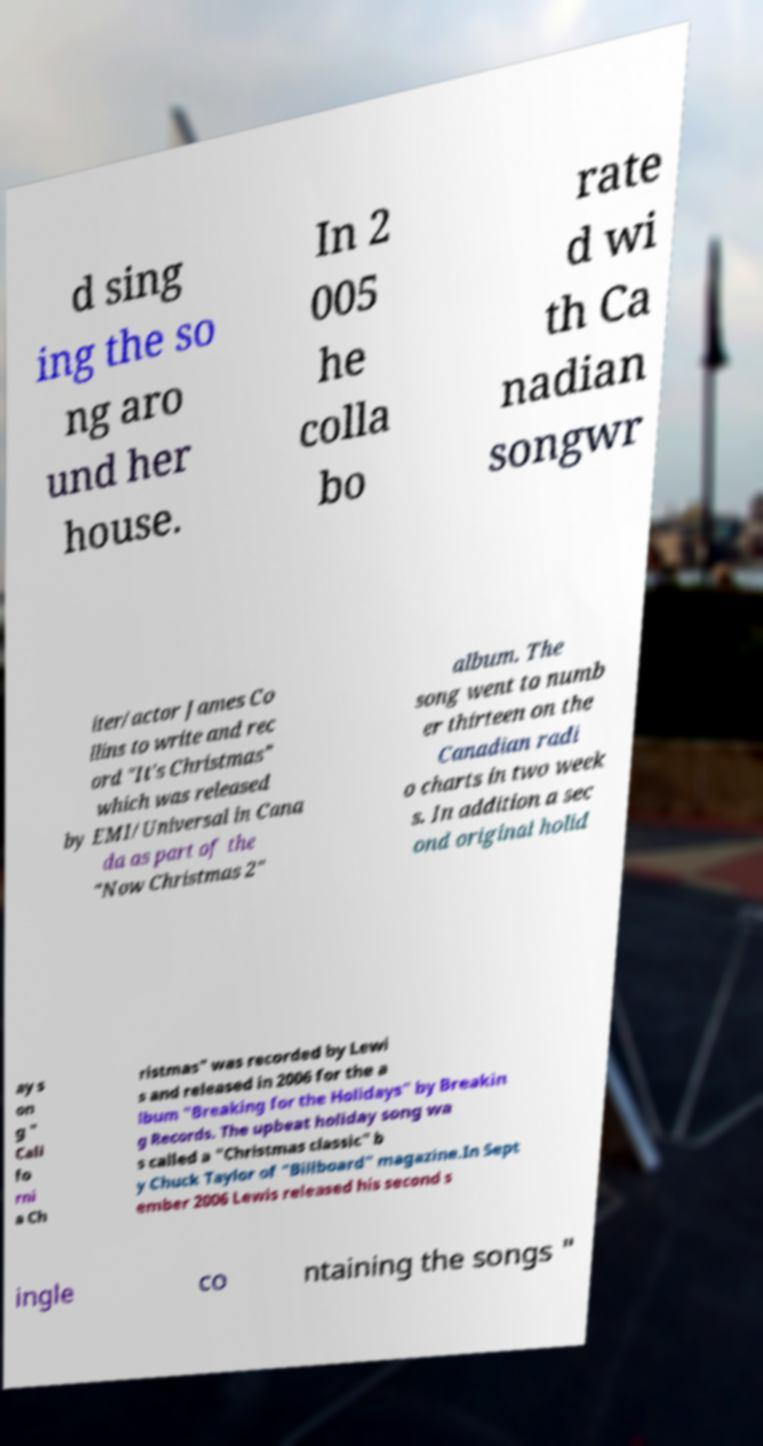Please read and relay the text visible in this image. What does it say? d sing ing the so ng aro und her house. In 2 005 he colla bo rate d wi th Ca nadian songwr iter/actor James Co llins to write and rec ord "It's Christmas" which was released by EMI/Universal in Cana da as part of the "Now Christmas 2" album. The song went to numb er thirteen on the Canadian radi o charts in two week s. In addition a sec ond original holid ay s on g " Cali fo rni a Ch ristmas" was recorded by Lewi s and released in 2006 for the a lbum "Breaking for the Holidays" by Breakin g Records. The upbeat holiday song wa s called a "Christmas classic" b y Chuck Taylor of "Billboard" magazine.In Sept ember 2006 Lewis released his second s ingle co ntaining the songs " 